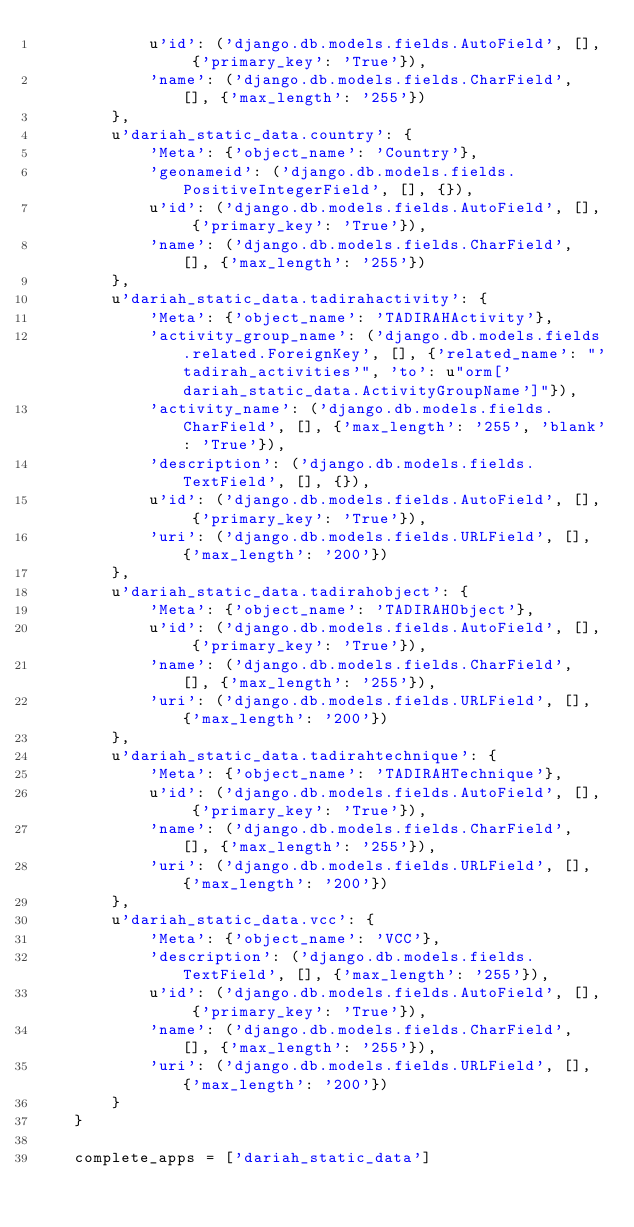Convert code to text. <code><loc_0><loc_0><loc_500><loc_500><_Python_>            u'id': ('django.db.models.fields.AutoField', [], {'primary_key': 'True'}),
            'name': ('django.db.models.fields.CharField', [], {'max_length': '255'})
        },
        u'dariah_static_data.country': {
            'Meta': {'object_name': 'Country'},
            'geonameid': ('django.db.models.fields.PositiveIntegerField', [], {}),
            u'id': ('django.db.models.fields.AutoField', [], {'primary_key': 'True'}),
            'name': ('django.db.models.fields.CharField', [], {'max_length': '255'})
        },
        u'dariah_static_data.tadirahactivity': {
            'Meta': {'object_name': 'TADIRAHActivity'},
            'activity_group_name': ('django.db.models.fields.related.ForeignKey', [], {'related_name': "'tadirah_activities'", 'to': u"orm['dariah_static_data.ActivityGroupName']"}),
            'activity_name': ('django.db.models.fields.CharField', [], {'max_length': '255', 'blank': 'True'}),
            'description': ('django.db.models.fields.TextField', [], {}),
            u'id': ('django.db.models.fields.AutoField', [], {'primary_key': 'True'}),
            'uri': ('django.db.models.fields.URLField', [], {'max_length': '200'})
        },
        u'dariah_static_data.tadirahobject': {
            'Meta': {'object_name': 'TADIRAHObject'},
            u'id': ('django.db.models.fields.AutoField', [], {'primary_key': 'True'}),
            'name': ('django.db.models.fields.CharField', [], {'max_length': '255'}),
            'uri': ('django.db.models.fields.URLField', [], {'max_length': '200'})
        },
        u'dariah_static_data.tadirahtechnique': {
            'Meta': {'object_name': 'TADIRAHTechnique'},
            u'id': ('django.db.models.fields.AutoField', [], {'primary_key': 'True'}),
            'name': ('django.db.models.fields.CharField', [], {'max_length': '255'}),
            'uri': ('django.db.models.fields.URLField', [], {'max_length': '200'})
        },
        u'dariah_static_data.vcc': {
            'Meta': {'object_name': 'VCC'},
            'description': ('django.db.models.fields.TextField', [], {'max_length': '255'}),
            u'id': ('django.db.models.fields.AutoField', [], {'primary_key': 'True'}),
            'name': ('django.db.models.fields.CharField', [], {'max_length': '255'}),
            'uri': ('django.db.models.fields.URLField', [], {'max_length': '200'})
        }
    }

    complete_apps = ['dariah_static_data']</code> 